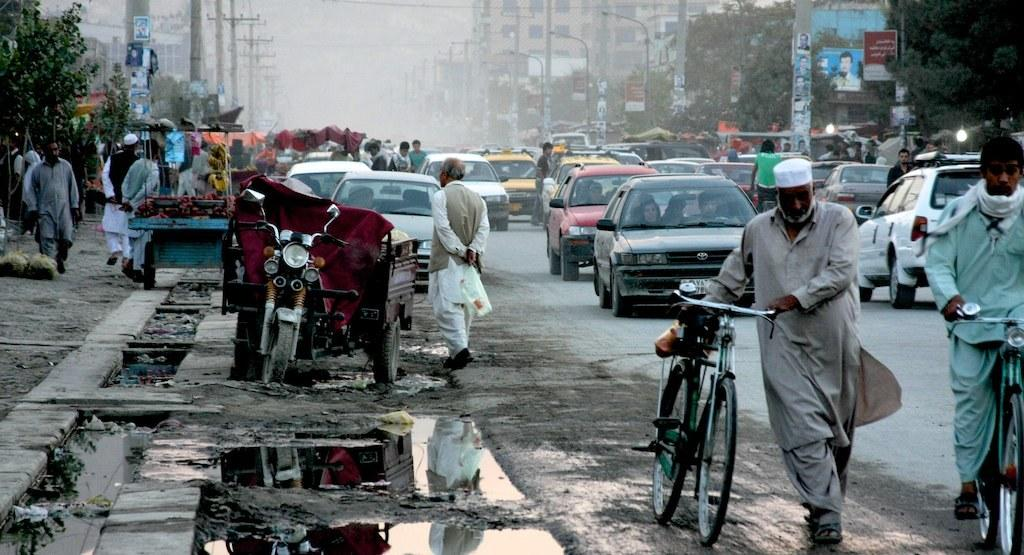What are the people in the image holding? The people in the image are holding bicycles. What can be seen on the road in the image? There are parked cars on the road in the image. Where are the people standing in the image? The people are standing on the footpath in the image. What type of quilt can be seen hanging from the window in the image? There is no quilt present in the image; it features people holding bicycles, parked cars, and people standing on the footpath. 